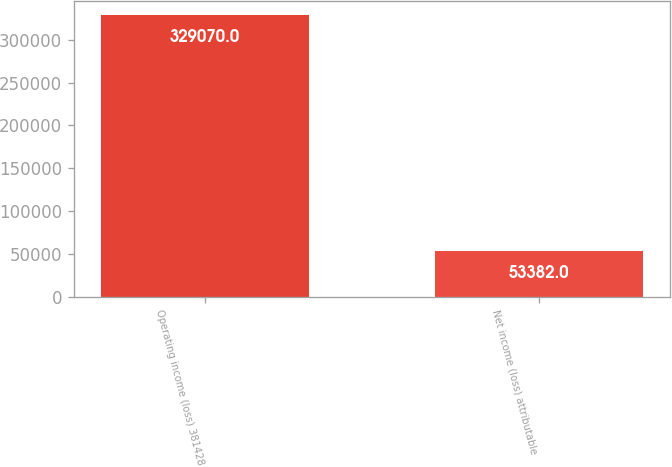Convert chart. <chart><loc_0><loc_0><loc_500><loc_500><bar_chart><fcel>Operating income (loss) 381428<fcel>Net income (loss) attributable<nl><fcel>329070<fcel>53382<nl></chart> 